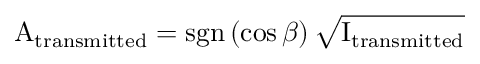Convert formula to latex. <formula><loc_0><loc_0><loc_500><loc_500>A _ { t r a n s m i t t e d } = s g n \left ( \cos { \beta } \right ) \sqrt { I _ { t r a n s m i t t e d } }</formula> 